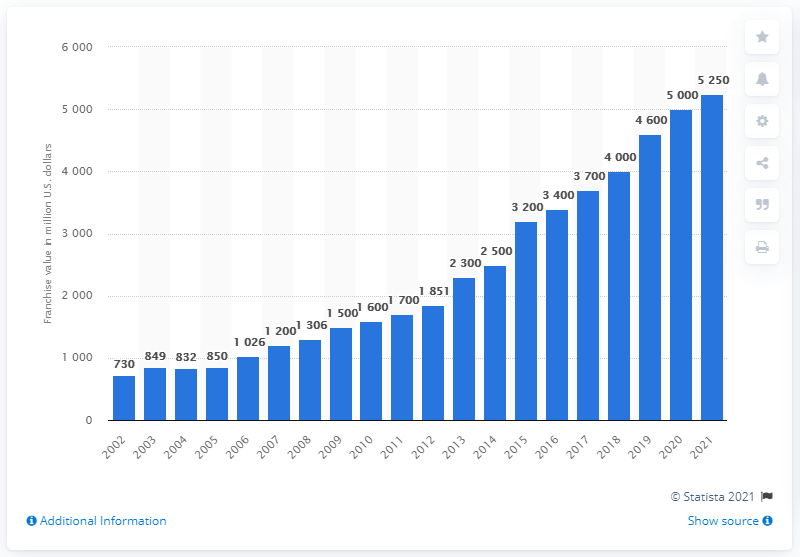Identify some key points in this picture. In 2021, the estimated value of the New York Yankees was 5,250. 